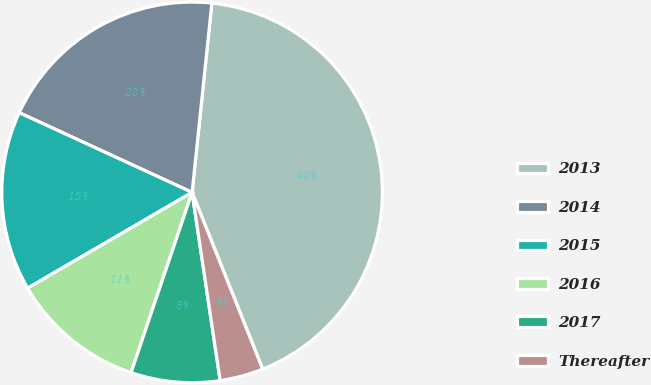Convert chart to OTSL. <chart><loc_0><loc_0><loc_500><loc_500><pie_chart><fcel>2013<fcel>2014<fcel>2015<fcel>2016<fcel>2017<fcel>Thereafter<nl><fcel>42.29%<fcel>19.78%<fcel>15.27%<fcel>11.41%<fcel>7.55%<fcel>3.69%<nl></chart> 